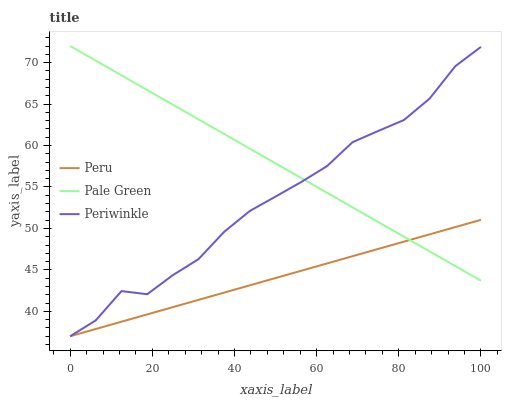Does Peru have the minimum area under the curve?
Answer yes or no. Yes. Does Pale Green have the maximum area under the curve?
Answer yes or no. Yes. Does Periwinkle have the minimum area under the curve?
Answer yes or no. No. Does Periwinkle have the maximum area under the curve?
Answer yes or no. No. Is Pale Green the smoothest?
Answer yes or no. Yes. Is Periwinkle the roughest?
Answer yes or no. Yes. Is Peru the smoothest?
Answer yes or no. No. Is Peru the roughest?
Answer yes or no. No. Does Periwinkle have the lowest value?
Answer yes or no. Yes. Does Pale Green have the highest value?
Answer yes or no. Yes. Does Periwinkle have the highest value?
Answer yes or no. No. Does Pale Green intersect Peru?
Answer yes or no. Yes. Is Pale Green less than Peru?
Answer yes or no. No. Is Pale Green greater than Peru?
Answer yes or no. No. 